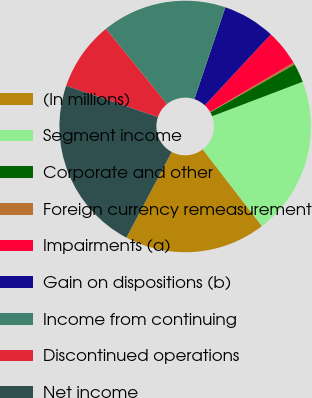<chart> <loc_0><loc_0><loc_500><loc_500><pie_chart><fcel>(In millions)<fcel>Segment income<fcel>Corporate and other<fcel>Foreign currency remeasurement<fcel>Impairments (a)<fcel>Gain on dispositions (b)<fcel>Income from continuing<fcel>Discontinued operations<fcel>Net income<nl><fcel>18.18%<fcel>20.34%<fcel>2.43%<fcel>0.27%<fcel>4.59%<fcel>6.75%<fcel>16.02%<fcel>8.91%<fcel>22.5%<nl></chart> 